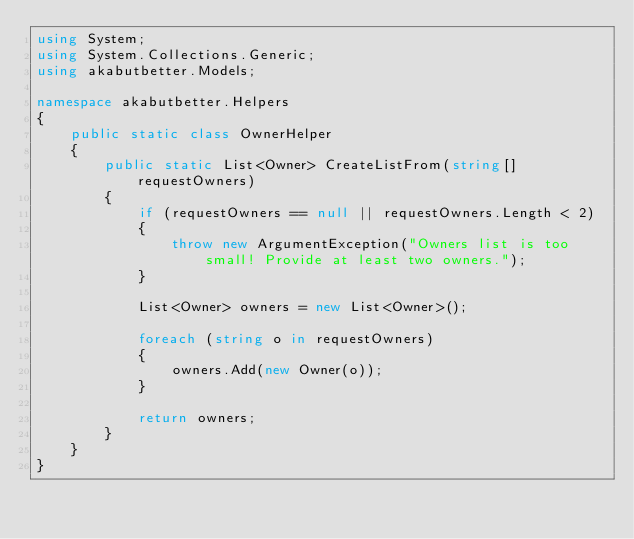<code> <loc_0><loc_0><loc_500><loc_500><_C#_>using System;
using System.Collections.Generic;
using akabutbetter.Models;

namespace akabutbetter.Helpers
{
    public static class OwnerHelper
    {
        public static List<Owner> CreateListFrom(string[] requestOwners)
        {
            if (requestOwners == null || requestOwners.Length < 2)
            {
                throw new ArgumentException("Owners list is too small! Provide at least two owners.");
            }
            
            List<Owner> owners = new List<Owner>();

            foreach (string o in requestOwners)
            {
                owners.Add(new Owner(o));
            }

            return owners;
        }
    }
}</code> 